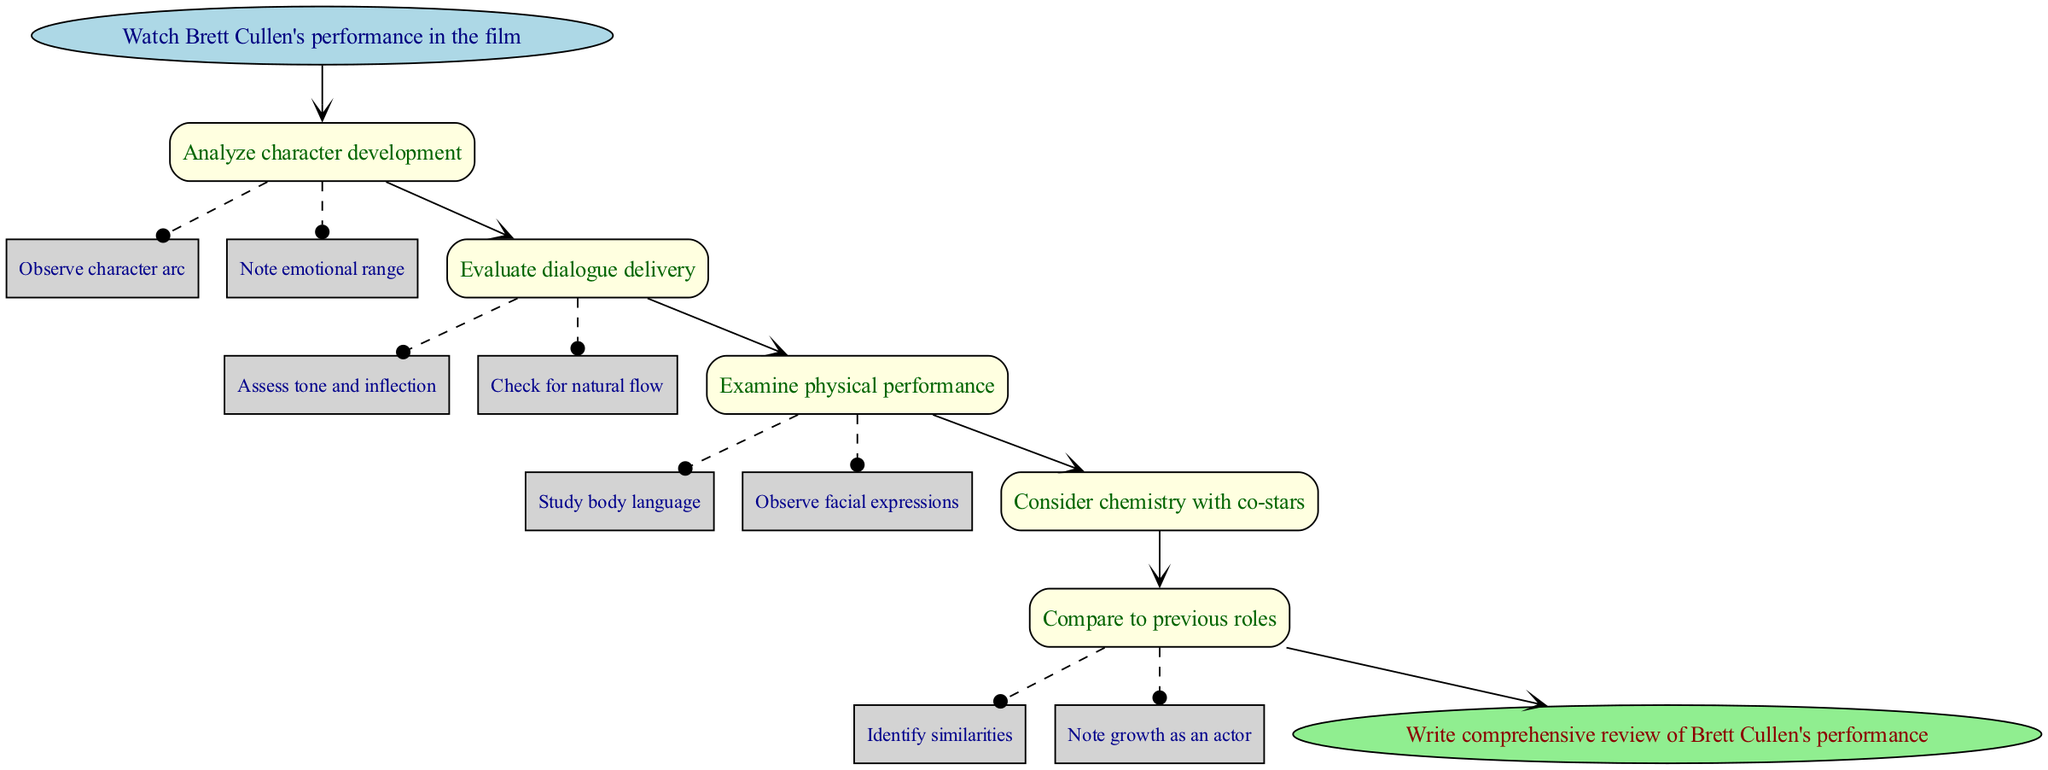What is the first step in analyzing Brett Cullen's performance? The first step is explicitly stated in the diagram as "Watch Brett Cullen's performance in the film." This is indicated by the start node leading to the first action in the analysis process.
Answer: Watch Brett Cullen's performance in the film How many main steps are there in the analysis process? To find the number of main steps, we can count each step listed. In the data provided, there are five main steps outlined, which can be verified by looking at the numbered steps in the diagram.
Answer: 5 Which step involves evaluating dialogue delivery? The step that specifically mentions dialogue delivery is step 2, titled "Evaluate dialogue delivery." This can be identified by the text associated with that node in the diagram.
Answer: Evaluate dialogue delivery What two sub-steps are included in analyzing character development? The sub-steps under character development (step 1) are "Observe character arc" and "Note emotional range." These sub-steps are visually represented as connected dashed lines to step 1 in the diagram.
Answer: Observe character arc, Note emotional range Which step is followed by the "Consider chemistry with co-stars"? "Consider chemistry with co-stars" is step 4 and it directly follows step 3, which is "Examine physical performance." This can be determined by tracing the arrows connecting the steps in the flowchart.
Answer: Examine physical performance What is the final action in the analysis process? The final action is denoted at the end of the flowchart, indicated by the end node, which states "Write comprehensive review of Brett Cullen's performance." This summarization reflects the conclusion of the analytical process.
Answer: Write comprehensive review of Brett Cullen's performance How many sub-steps are there in total across all steps? To obtain the total number of sub-steps, we can count the sub-steps listed under steps 1, 2, and 5. There are two sub-steps in step 1, two in step 2, and two in step 5, giving us a total of six sub-steps.
Answer: 6 Which step occurs before "Compare to previous roles"? The step that occurs immediately before "Compare to previous roles" is step 4, "Consider chemistry with co-stars." This can be confirmed by looking at the arrangement of steps in the flowchart from one to the next.
Answer: Consider chemistry with co-stars What is the relationship between "Analyze character development" and "Evaluate dialogue delivery"? The relationship is sequential, as "Analyze character development" is step 1 while "Evaluate dialogue delivery" is step 2, indicating that the first step leads to the second. This is shown by the flowing arrows in the direction of the analysis.
Answer: Sequential relationship 